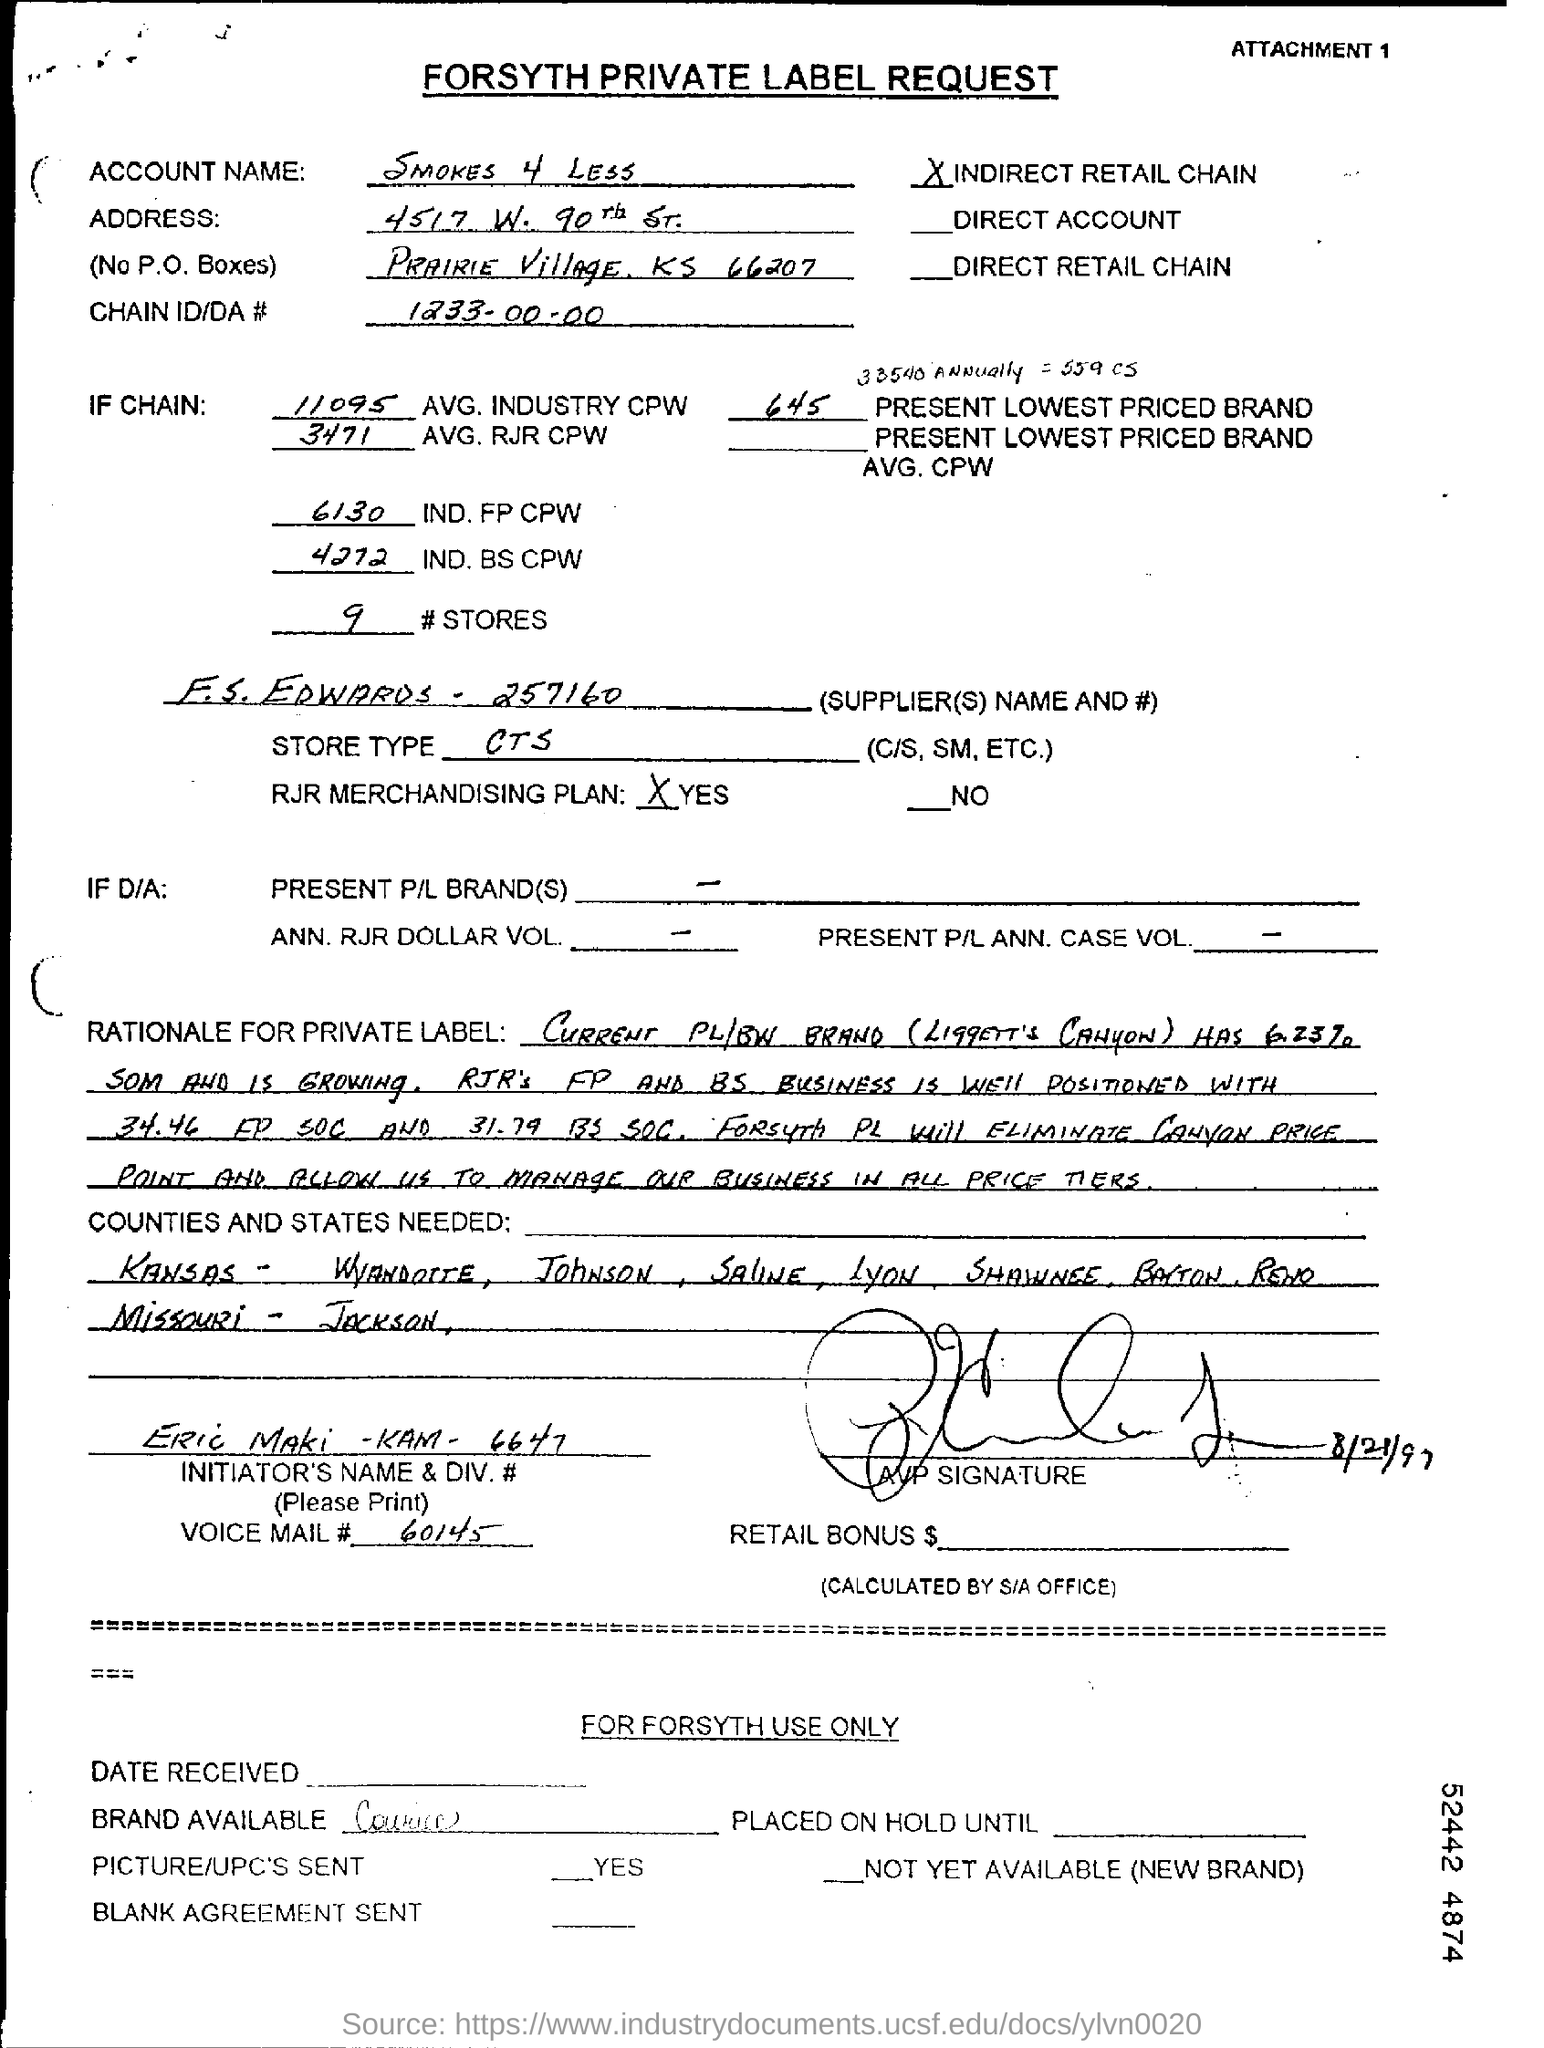What is suppliers name?
Your answer should be very brief. F.S. EDWARDS. What is the store type mentioned in the form?
Ensure brevity in your answer.  CTS. 